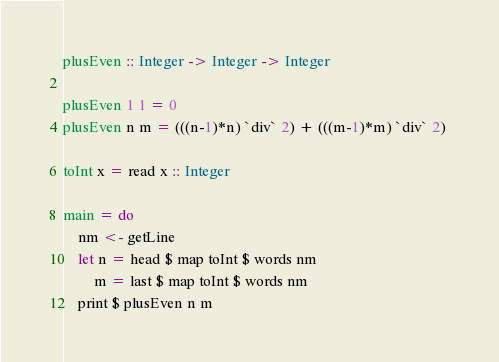Convert code to text. <code><loc_0><loc_0><loc_500><loc_500><_Haskell_>plusEven :: Integer -> Integer -> Integer

plusEven 1 1 = 0
plusEven n m = (((n-1)*n) `div` 2) + (((m-1)*m) `div` 2) 

toInt x = read x :: Integer

main = do
    nm <- getLine
    let n = head $ map toInt $ words nm
        m = last $ map toInt $ words nm
    print $ plusEven n m</code> 